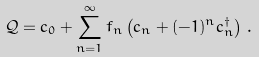<formula> <loc_0><loc_0><loc_500><loc_500>\mathcal { Q } = c _ { 0 } + \sum _ { n = 1 } ^ { \infty } f _ { n } \left ( c _ { n } + ( - 1 ) ^ { n } c _ { n } ^ { \dagger } \right ) \, .</formula> 